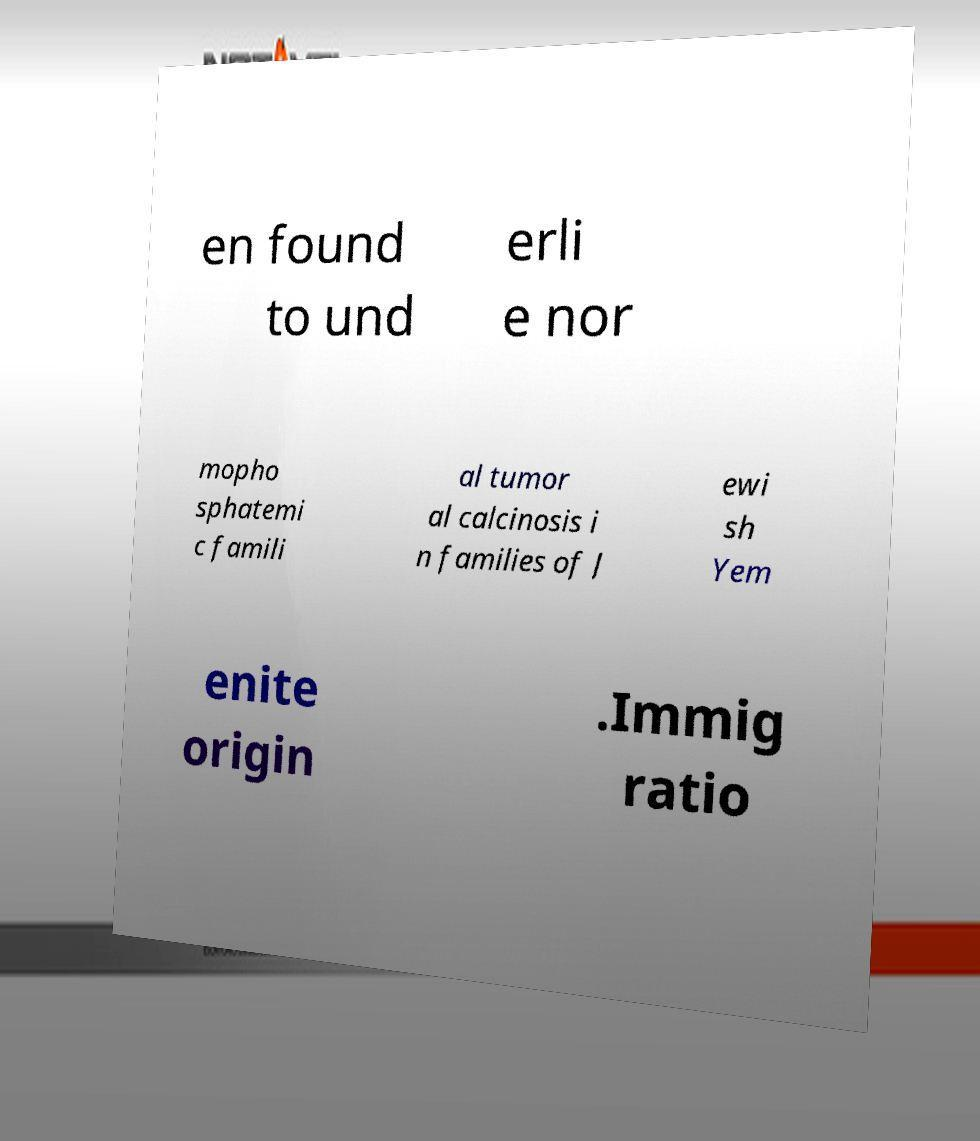Could you assist in decoding the text presented in this image and type it out clearly? en found to und erli e nor mopho sphatemi c famili al tumor al calcinosis i n families of J ewi sh Yem enite origin .Immig ratio 